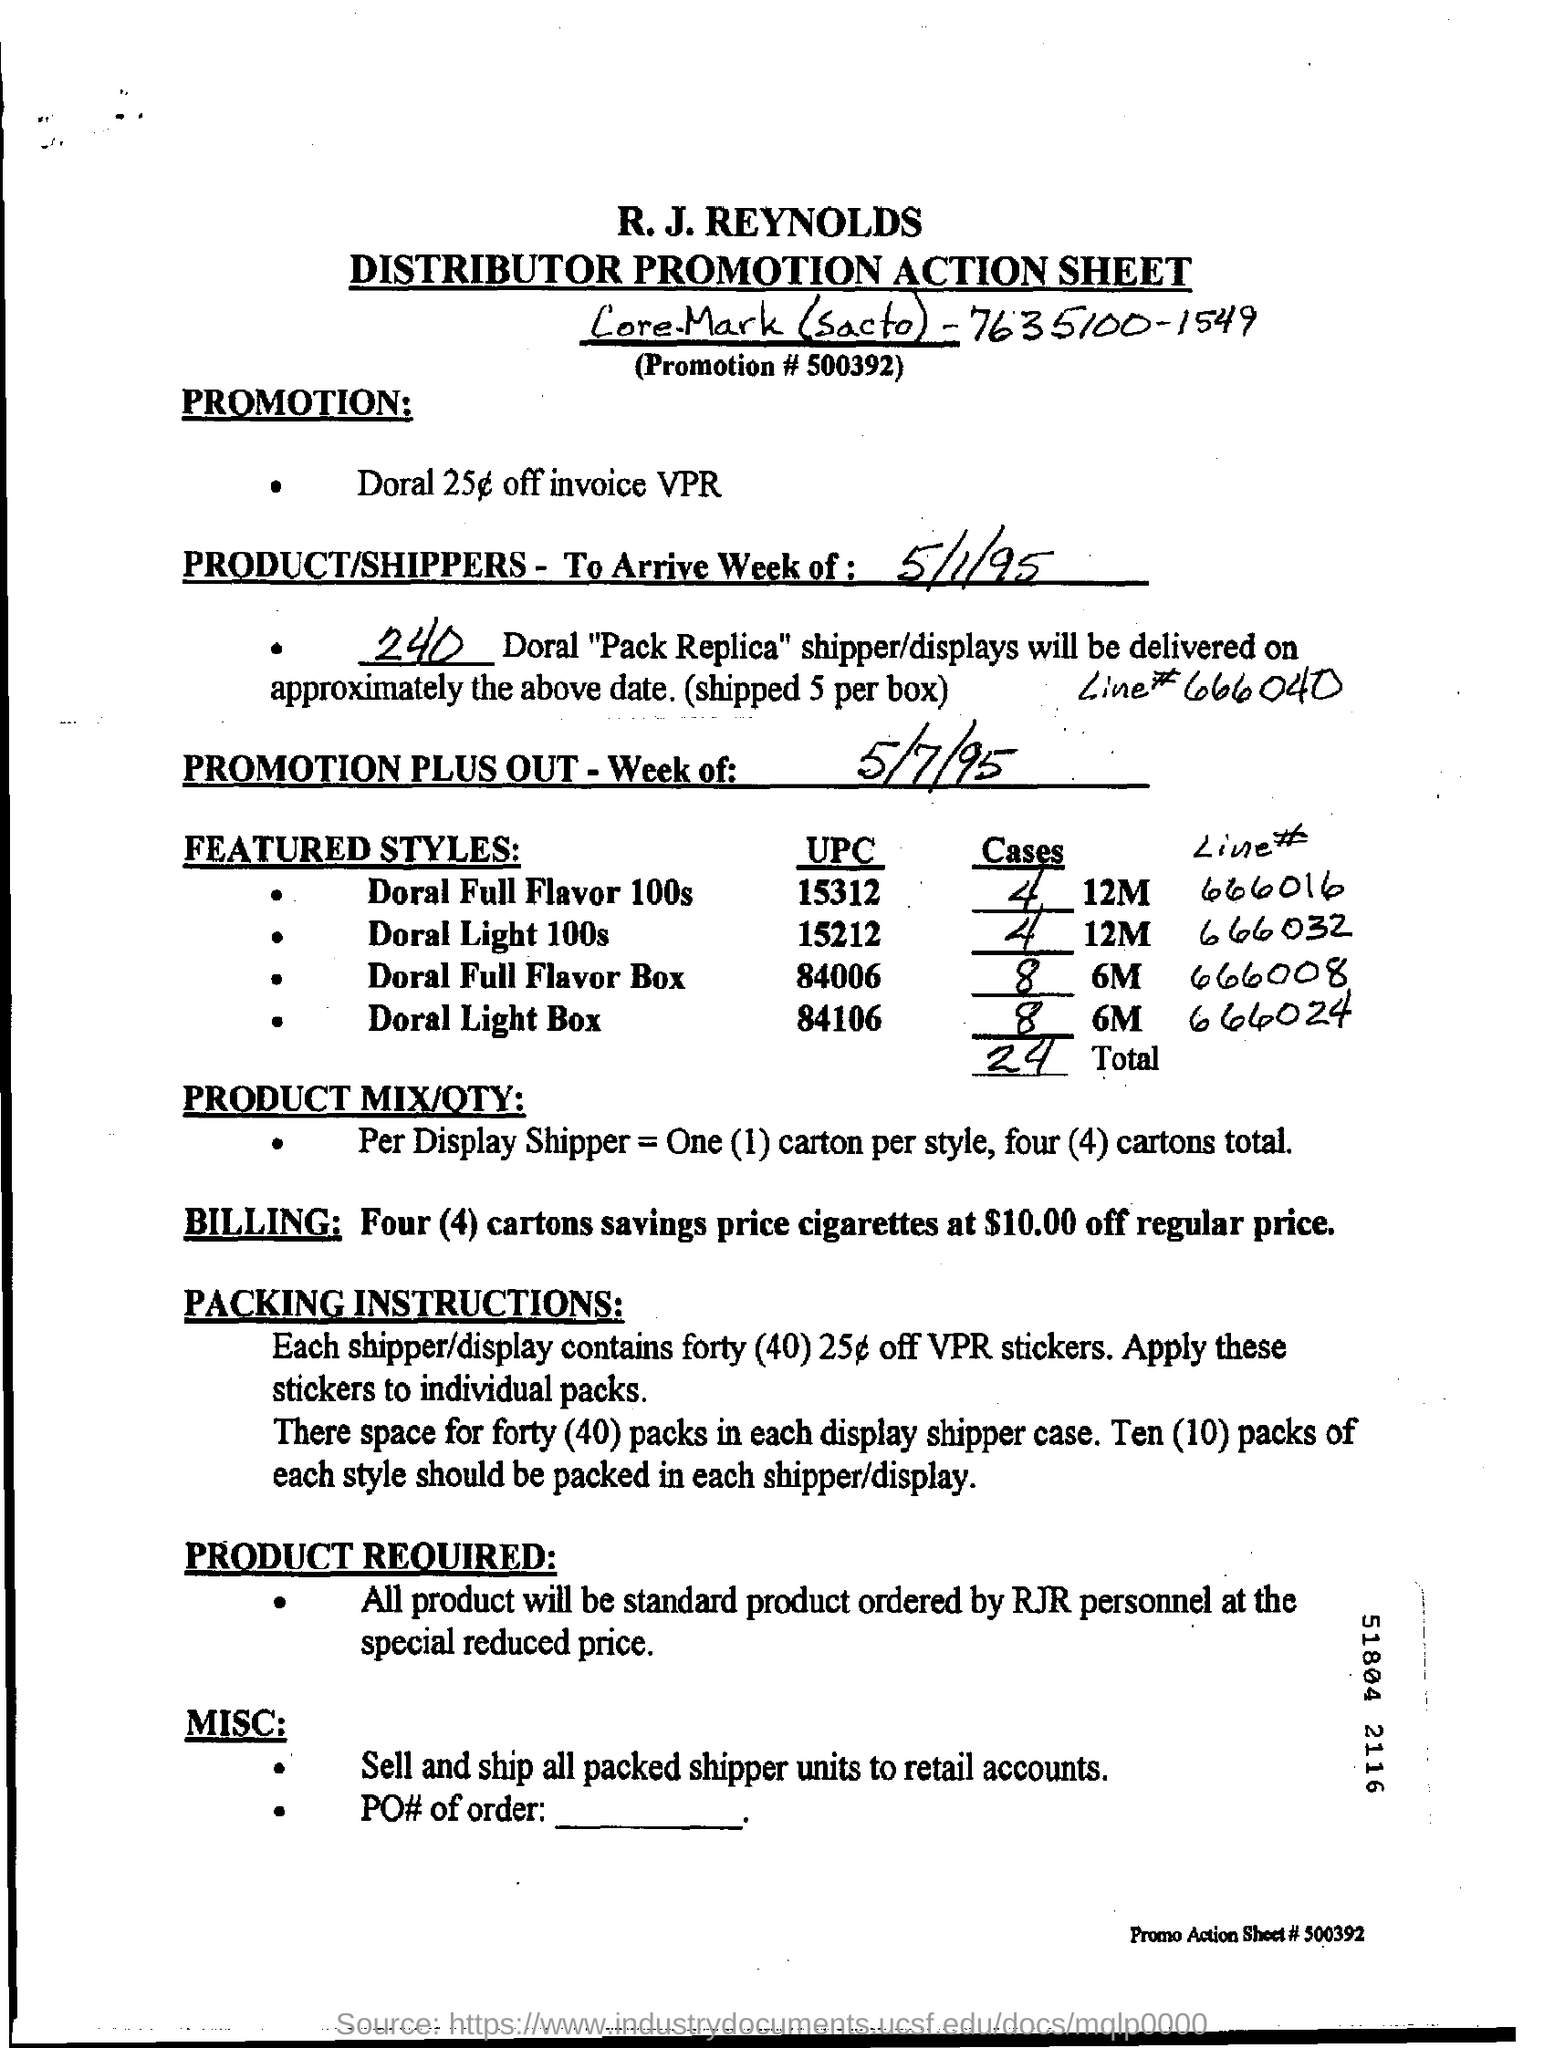Indicate a few pertinent items in this graphic. The promotion number is 500392... Doral is offering a promotion of 25 cents off invoices with the code VPR. It is expected that members of RJR personnel will be the ones to order the standard product at the special reduced price. The delivery of Doral "Pack Replica" shipper/displays will be 240 in total. Each shipper and display contains 25 coupon offers with a face value of $25 off a purchase of $250 or more from VPR stores. 